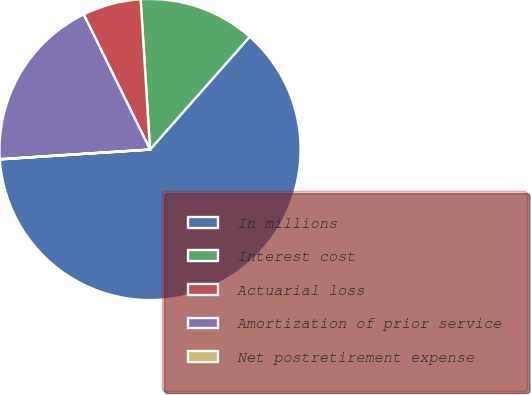Convert chart. <chart><loc_0><loc_0><loc_500><loc_500><pie_chart><fcel>In millions<fcel>Interest cost<fcel>Actuarial loss<fcel>Amortization of prior service<fcel>Net postretirement expense<nl><fcel>62.43%<fcel>12.51%<fcel>6.27%<fcel>18.75%<fcel>0.03%<nl></chart> 